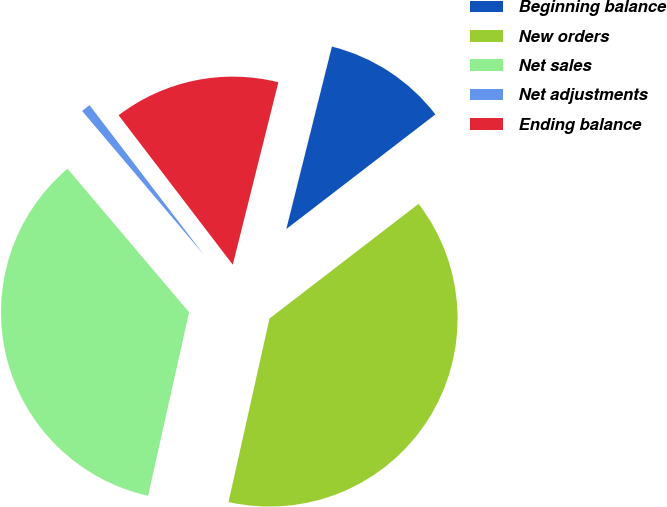Convert chart to OTSL. <chart><loc_0><loc_0><loc_500><loc_500><pie_chart><fcel>Beginning balance<fcel>New orders<fcel>Net sales<fcel>Net adjustments<fcel>Ending balance<nl><fcel>10.67%<fcel>38.93%<fcel>35.32%<fcel>0.8%<fcel>14.28%<nl></chart> 